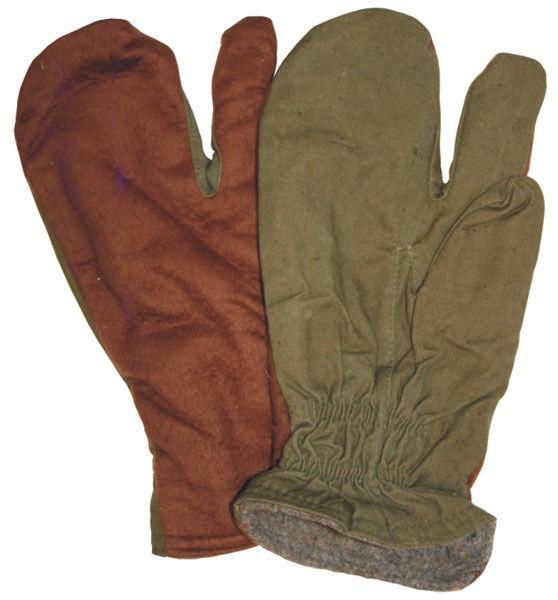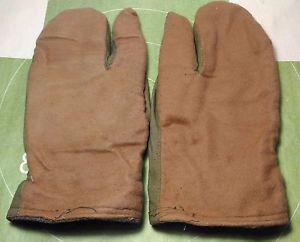The first image is the image on the left, the second image is the image on the right. Given the left and right images, does the statement "Each image contains one complete pair of mittens designed with one finger separated from the rest." hold true? Answer yes or no. Yes. The first image is the image on the left, the second image is the image on the right. Analyze the images presented: Is the assertion "Both images show the front and back side of a pair of gloves." valid? Answer yes or no. No. 